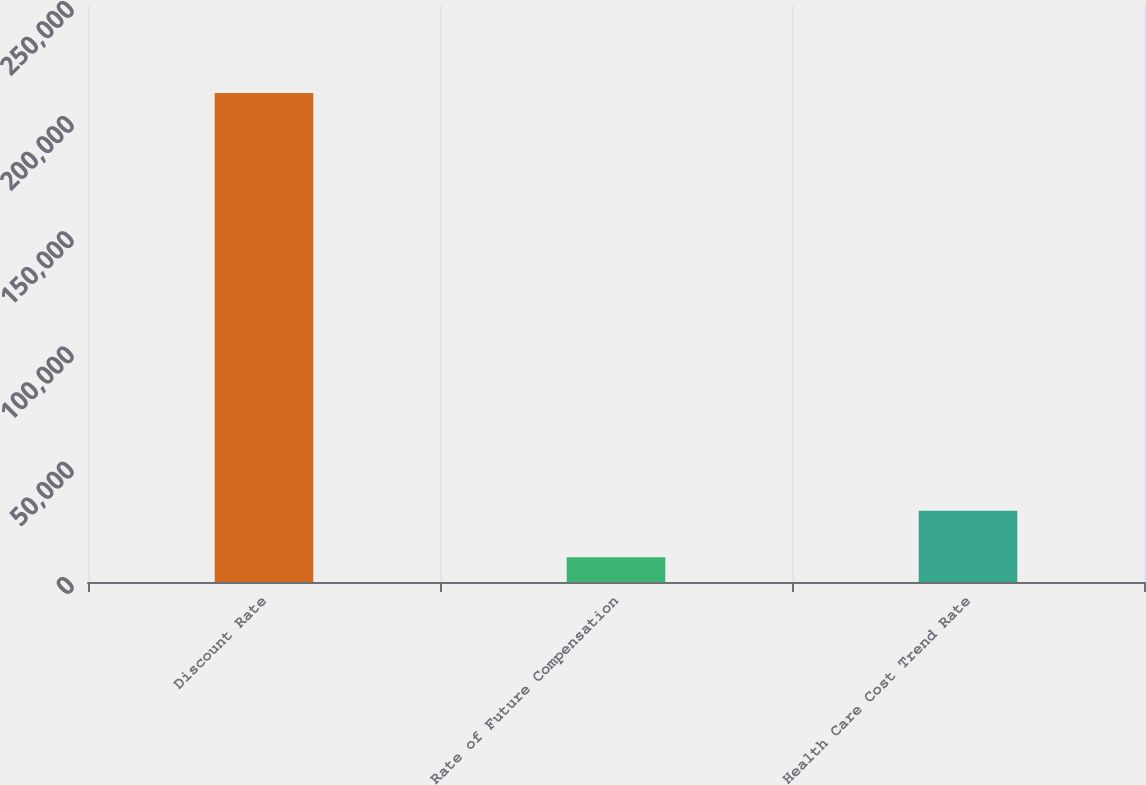Convert chart. <chart><loc_0><loc_0><loc_500><loc_500><bar_chart><fcel>Discount Rate<fcel>Rate of Future Compensation<fcel>Health Care Cost Trend Rate<nl><fcel>212189<fcel>10730<fcel>30875.9<nl></chart> 